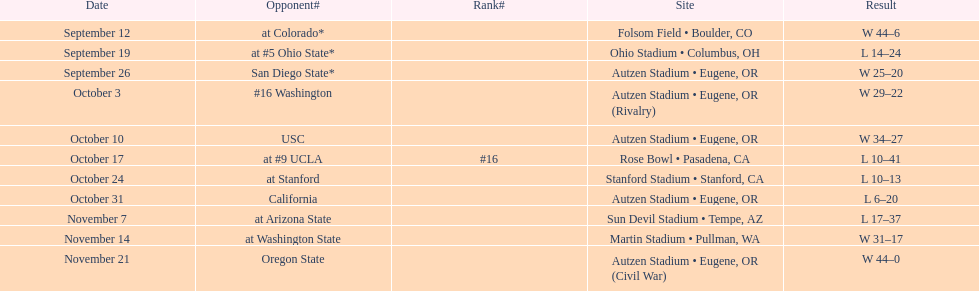Were the scores of the november 14 contest more or less than the scores of the october 17 contest? Above. 